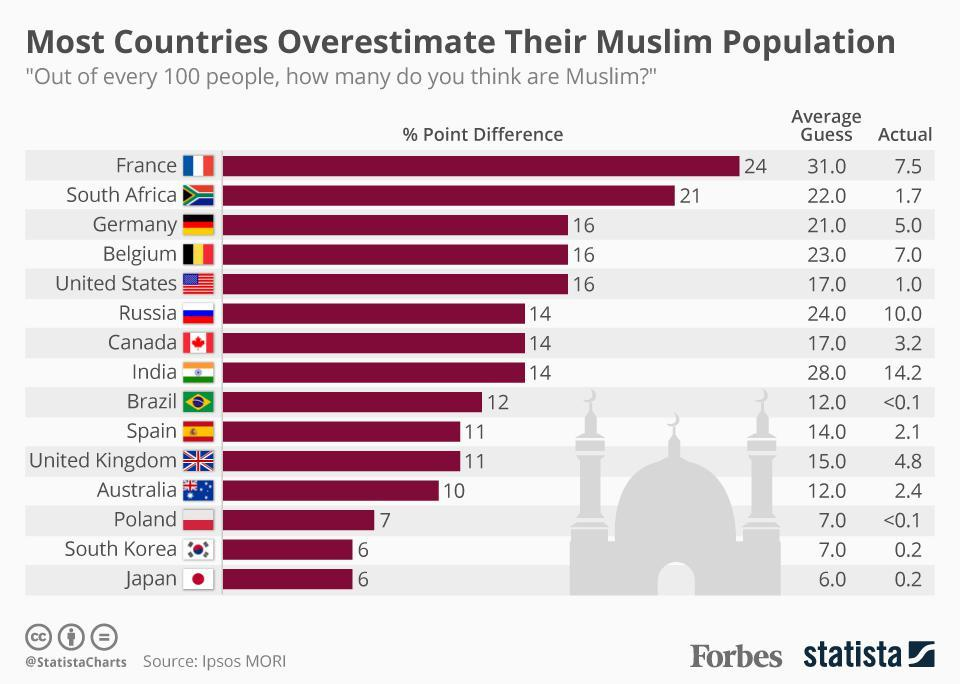Give some essential details in this illustration. There are six countries out of the total number of countries whose percentage point difference is equal to 6. All countries with a percentage point difference of 6 are South Korea and Japan. 